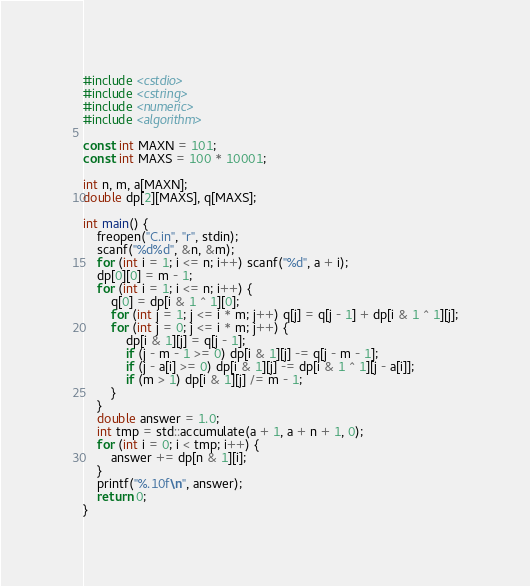<code> <loc_0><loc_0><loc_500><loc_500><_C++_>#include <cstdio>
#include <cstring>
#include <numeric>
#include <algorithm>

const int MAXN = 101;
const int MAXS = 100 * 10001;

int n, m, a[MAXN];
double dp[2][MAXS], q[MAXS];

int main() {
	freopen("C.in", "r", stdin);
	scanf("%d%d", &n, &m);
	for (int i = 1; i <= n; i++) scanf("%d", a + i);
	dp[0][0] = m - 1;
	for (int i = 1; i <= n; i++) {
		q[0] = dp[i & 1 ^ 1][0];
		for (int j = 1; j <= i * m; j++) q[j] = q[j - 1] + dp[i & 1 ^ 1][j];
		for (int j = 0; j <= i * m; j++) {
			dp[i & 1][j] = q[j - 1];
			if (j - m - 1 >= 0) dp[i & 1][j] -= q[j - m - 1];
			if (j - a[i] >= 0) dp[i & 1][j] -= dp[i & 1 ^ 1][j - a[i]];
			if (m > 1) dp[i & 1][j] /= m - 1;
		}
	}
	double answer = 1.0;
	int tmp = std::accumulate(a + 1, a + n + 1, 0);
	for (int i = 0; i < tmp; i++) {
		answer += dp[n & 1][i];
	}
	printf("%.10f\n", answer);
	return 0;
}
</code> 